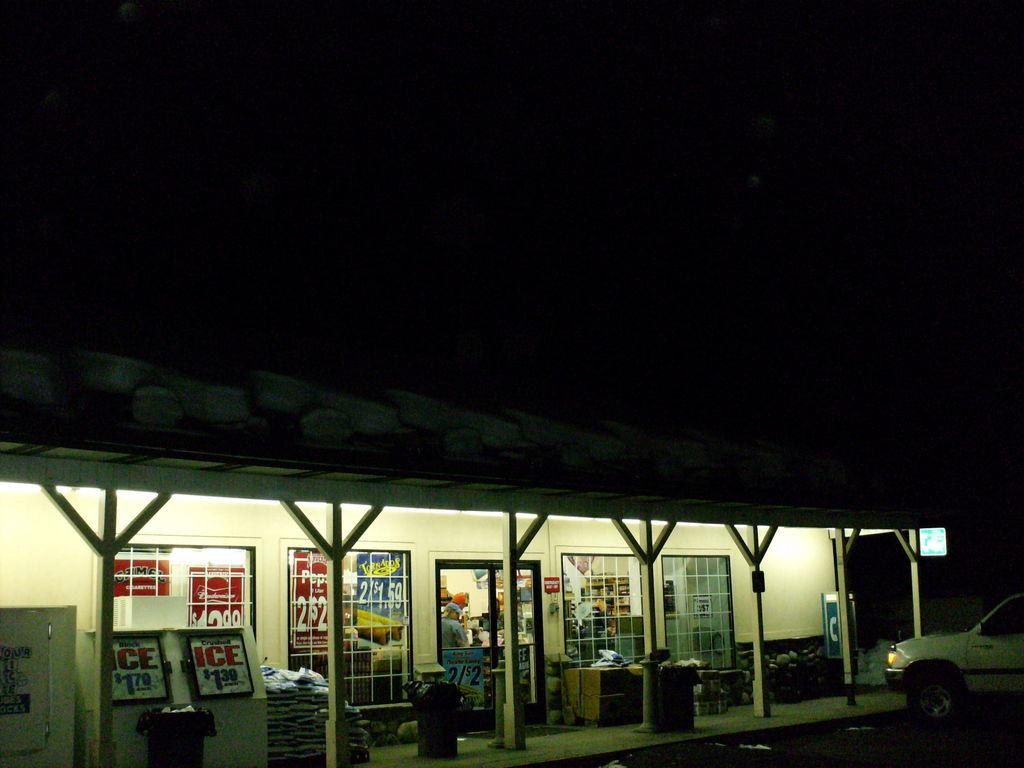What type of vehicle is in the image? The facts do not specify the type of vehicle. What can be seen in the image besides the vehicle? There are poles, a building, windows, a door, and a person visible in the image. What is the purpose of the poles in the image? The facts do not specify the purpose of the poles. What is the building in the image made of? The facts do not specify the material of the building. How many windows are visible in the image? There are windows visible in the image, but the exact number is not specified. What is the person in the image doing? The facts do not specify the actions of the person. What is visible in the background of the image? The sky is visible in the background of the image. What type of bun is the person holding in the image? There is no mention of a bun or any other type of bun in the image. 